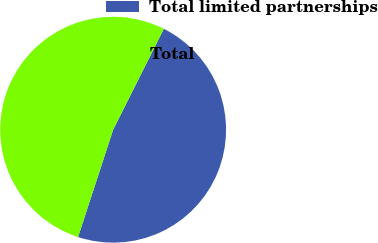Convert chart to OTSL. <chart><loc_0><loc_0><loc_500><loc_500><pie_chart><fcel>Total limited partnerships<fcel>Total<nl><fcel>47.62%<fcel>52.38%<nl></chart> 